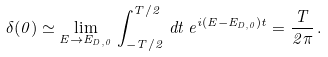<formula> <loc_0><loc_0><loc_500><loc_500>\delta ( 0 ) \simeq \lim _ { E \rightarrow E _ { D , 0 } } \, \int _ { - T / 2 } ^ { T / 2 } \, d t \, e ^ { i ( E - E _ { D , 0 } ) t } = \frac { T } { 2 \pi } \, .</formula> 